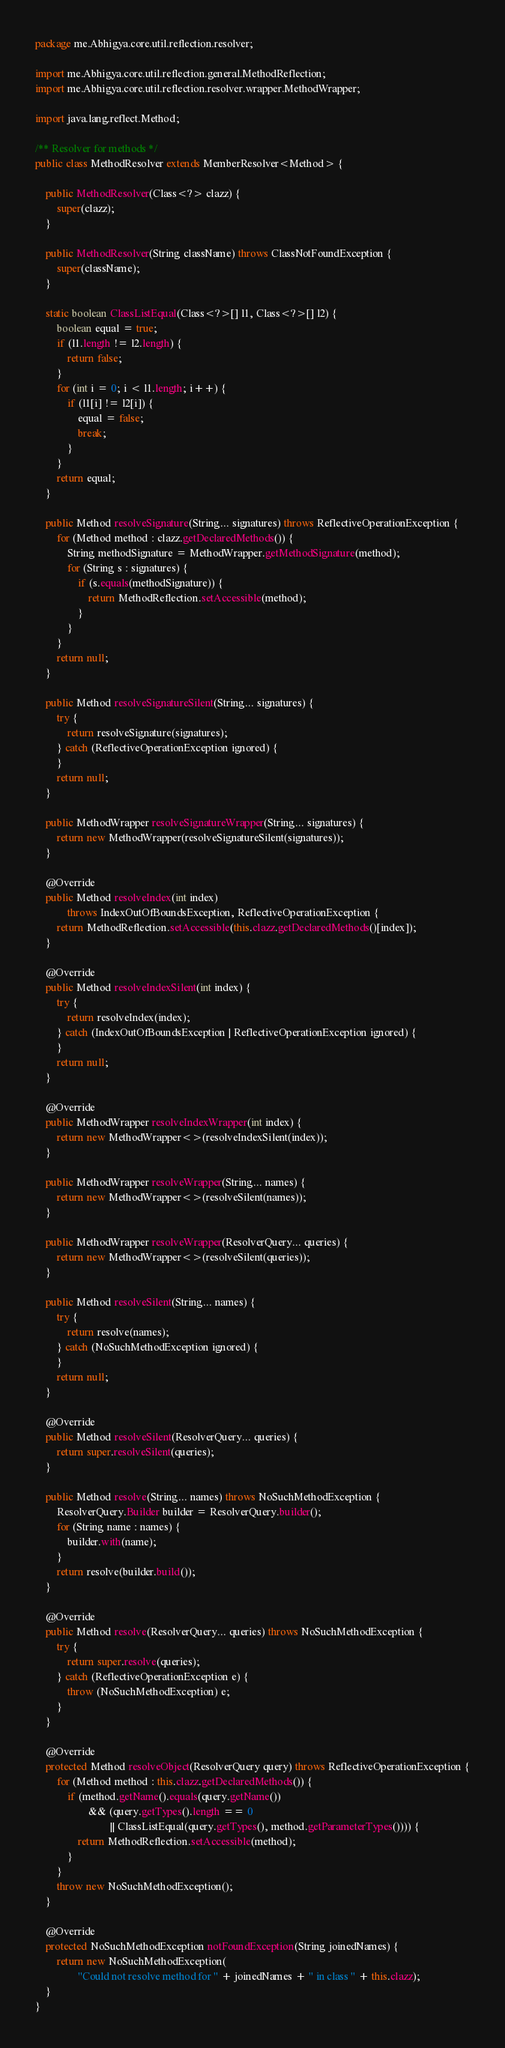Convert code to text. <code><loc_0><loc_0><loc_500><loc_500><_Java_>package me.Abhigya.core.util.reflection.resolver;

import me.Abhigya.core.util.reflection.general.MethodReflection;
import me.Abhigya.core.util.reflection.resolver.wrapper.MethodWrapper;

import java.lang.reflect.Method;

/** Resolver for methods */
public class MethodResolver extends MemberResolver<Method> {

    public MethodResolver(Class<?> clazz) {
        super(clazz);
    }

    public MethodResolver(String className) throws ClassNotFoundException {
        super(className);
    }

    static boolean ClassListEqual(Class<?>[] l1, Class<?>[] l2) {
        boolean equal = true;
        if (l1.length != l2.length) {
            return false;
        }
        for (int i = 0; i < l1.length; i++) {
            if (l1[i] != l2[i]) {
                equal = false;
                break;
            }
        }
        return equal;
    }

    public Method resolveSignature(String... signatures) throws ReflectiveOperationException {
        for (Method method : clazz.getDeclaredMethods()) {
            String methodSignature = MethodWrapper.getMethodSignature(method);
            for (String s : signatures) {
                if (s.equals(methodSignature)) {
                    return MethodReflection.setAccessible(method);
                }
            }
        }
        return null;
    }

    public Method resolveSignatureSilent(String... signatures) {
        try {
            return resolveSignature(signatures);
        } catch (ReflectiveOperationException ignored) {
        }
        return null;
    }

    public MethodWrapper resolveSignatureWrapper(String... signatures) {
        return new MethodWrapper(resolveSignatureSilent(signatures));
    }

    @Override
    public Method resolveIndex(int index)
            throws IndexOutOfBoundsException, ReflectiveOperationException {
        return MethodReflection.setAccessible(this.clazz.getDeclaredMethods()[index]);
    }

    @Override
    public Method resolveIndexSilent(int index) {
        try {
            return resolveIndex(index);
        } catch (IndexOutOfBoundsException | ReflectiveOperationException ignored) {
        }
        return null;
    }

    @Override
    public MethodWrapper resolveIndexWrapper(int index) {
        return new MethodWrapper<>(resolveIndexSilent(index));
    }

    public MethodWrapper resolveWrapper(String... names) {
        return new MethodWrapper<>(resolveSilent(names));
    }

    public MethodWrapper resolveWrapper(ResolverQuery... queries) {
        return new MethodWrapper<>(resolveSilent(queries));
    }

    public Method resolveSilent(String... names) {
        try {
            return resolve(names);
        } catch (NoSuchMethodException ignored) {
        }
        return null;
    }

    @Override
    public Method resolveSilent(ResolverQuery... queries) {
        return super.resolveSilent(queries);
    }

    public Method resolve(String... names) throws NoSuchMethodException {
        ResolverQuery.Builder builder = ResolverQuery.builder();
        for (String name : names) {
            builder.with(name);
        }
        return resolve(builder.build());
    }

    @Override
    public Method resolve(ResolverQuery... queries) throws NoSuchMethodException {
        try {
            return super.resolve(queries);
        } catch (ReflectiveOperationException e) {
            throw (NoSuchMethodException) e;
        }
    }

    @Override
    protected Method resolveObject(ResolverQuery query) throws ReflectiveOperationException {
        for (Method method : this.clazz.getDeclaredMethods()) {
            if (method.getName().equals(query.getName())
                    && (query.getTypes().length == 0
                            || ClassListEqual(query.getTypes(), method.getParameterTypes()))) {
                return MethodReflection.setAccessible(method);
            }
        }
        throw new NoSuchMethodException();
    }

    @Override
    protected NoSuchMethodException notFoundException(String joinedNames) {
        return new NoSuchMethodException(
                "Could not resolve method for " + joinedNames + " in class " + this.clazz);
    }
}
</code> 